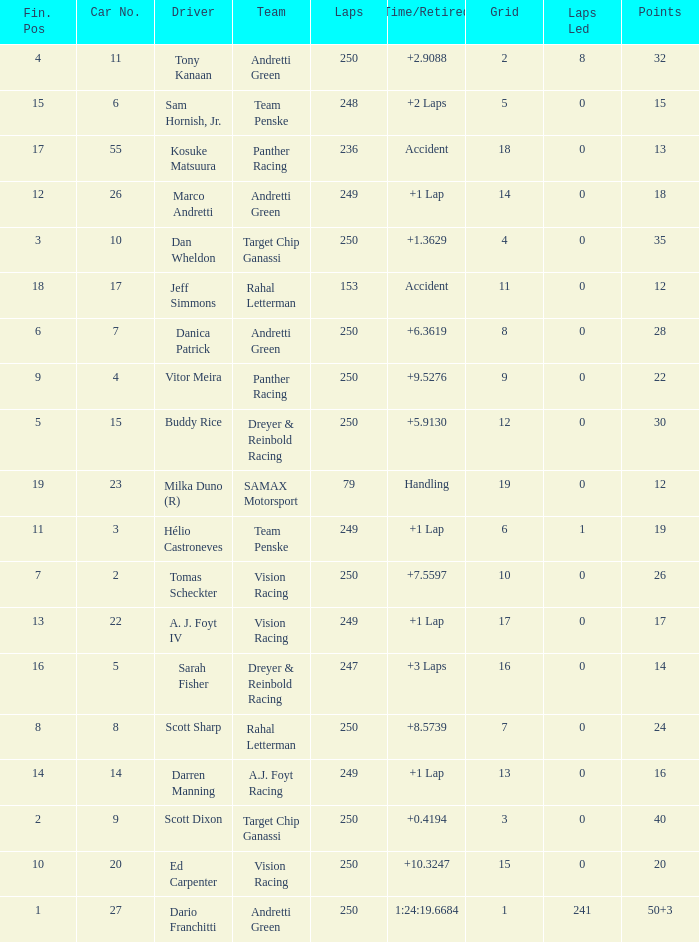Name the total number of cars for panther racing and grid of 9 1.0. 